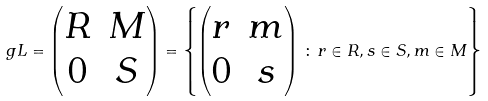<formula> <loc_0><loc_0><loc_500><loc_500>\ g L = \begin{pmatrix} R & M \\ 0 & S \end{pmatrix} = \left \{ \begin{pmatrix} r & m \\ 0 & s \end{pmatrix} \, \colon \, r \in R , s \in S , m \in M \right \}</formula> 